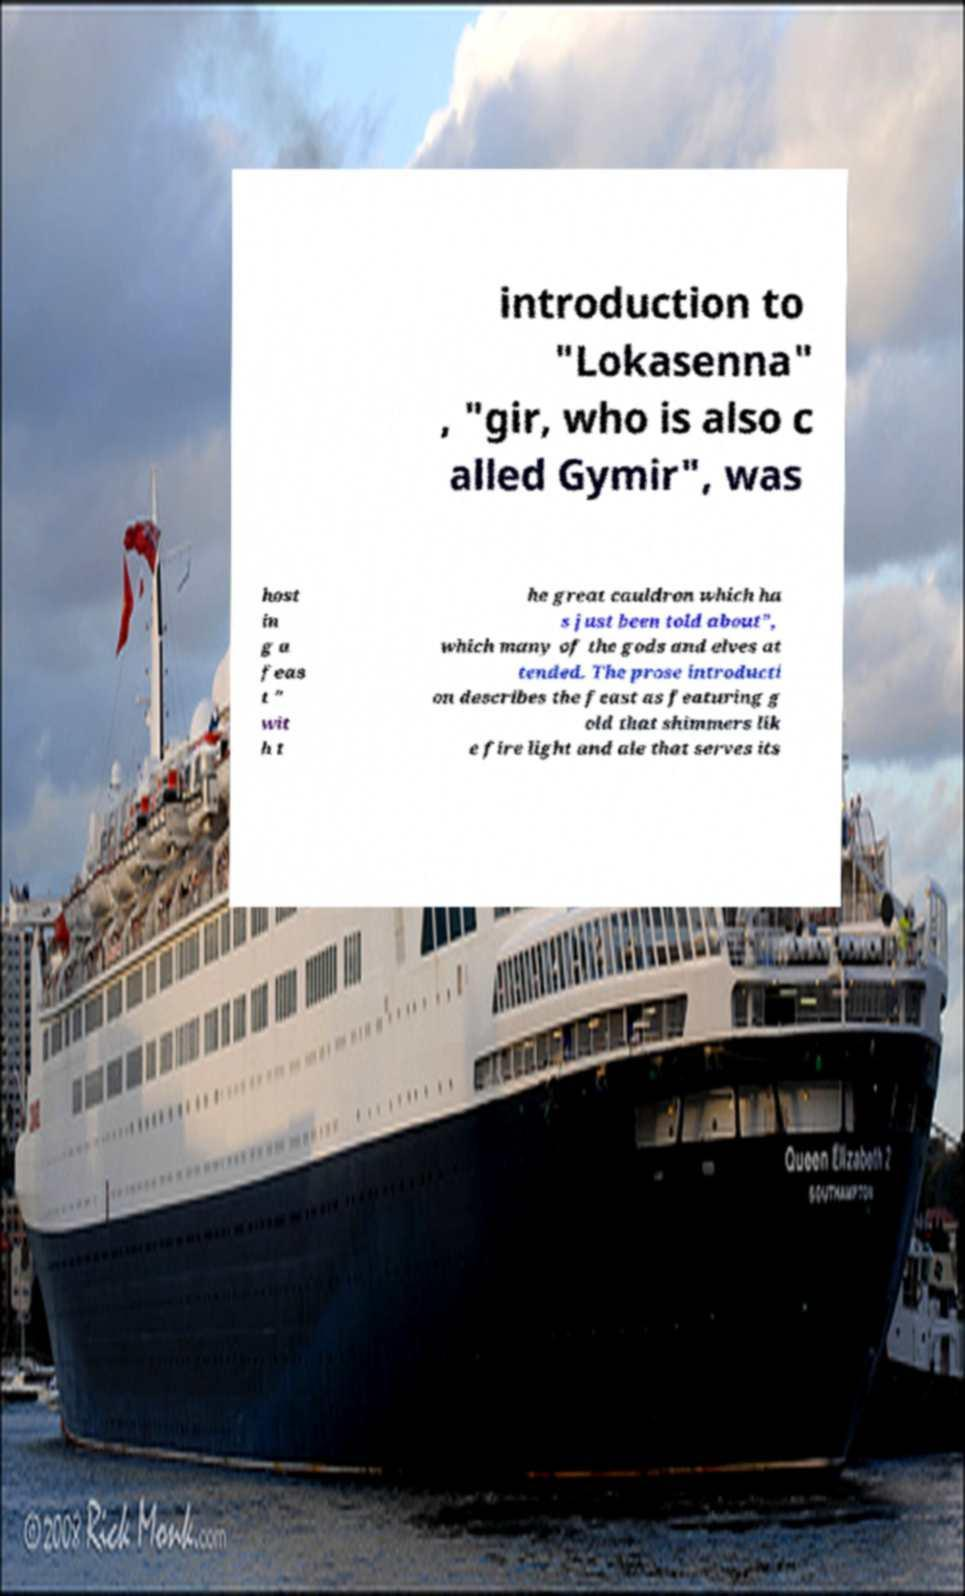Please identify and transcribe the text found in this image. introduction to "Lokasenna" , "gir, who is also c alled Gymir", was host in g a feas t " wit h t he great cauldron which ha s just been told about", which many of the gods and elves at tended. The prose introducti on describes the feast as featuring g old that shimmers lik e fire light and ale that serves its 